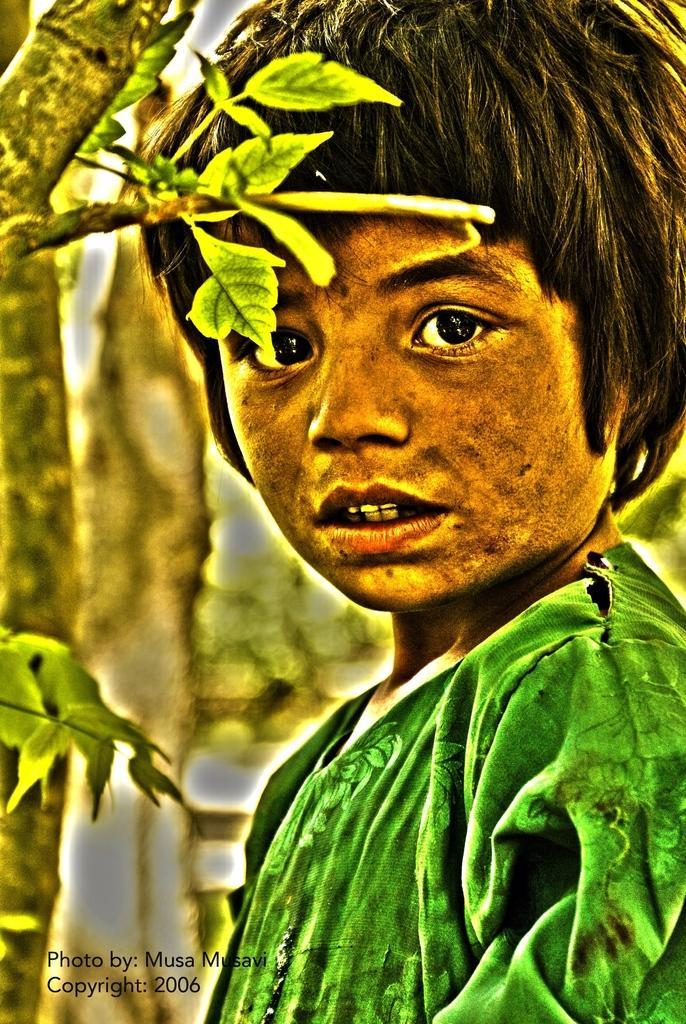Please provide a concise description of this image. This is an edited image, we can see a person. Behind the person there are trees and on the image there is a watermark. 